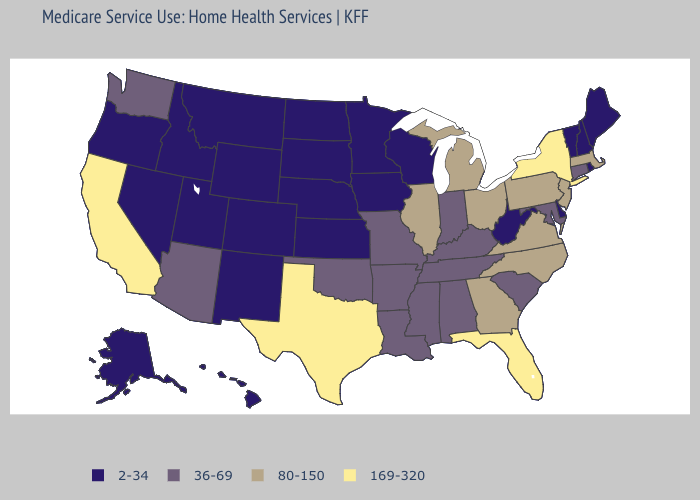What is the value of Kansas?
Short answer required. 2-34. Does Alabama have a lower value than West Virginia?
Concise answer only. No. What is the value of Iowa?
Keep it brief. 2-34. Which states have the lowest value in the USA?
Keep it brief. Alaska, Colorado, Delaware, Hawaii, Idaho, Iowa, Kansas, Maine, Minnesota, Montana, Nebraska, Nevada, New Hampshire, New Mexico, North Dakota, Oregon, Rhode Island, South Dakota, Utah, Vermont, West Virginia, Wisconsin, Wyoming. Name the states that have a value in the range 80-150?
Be succinct. Georgia, Illinois, Massachusetts, Michigan, New Jersey, North Carolina, Ohio, Pennsylvania, Virginia. What is the value of Hawaii?
Answer briefly. 2-34. What is the lowest value in the Northeast?
Quick response, please. 2-34. Does Pennsylvania have the lowest value in the USA?
Answer briefly. No. Name the states that have a value in the range 169-320?
Write a very short answer. California, Florida, New York, Texas. Does Idaho have the same value as North Dakota?
Write a very short answer. Yes. What is the value of Missouri?
Write a very short answer. 36-69. Does Wisconsin have the highest value in the MidWest?
Write a very short answer. No. Does Rhode Island have the highest value in the Northeast?
Short answer required. No. Which states hav the highest value in the South?
Short answer required. Florida, Texas. 